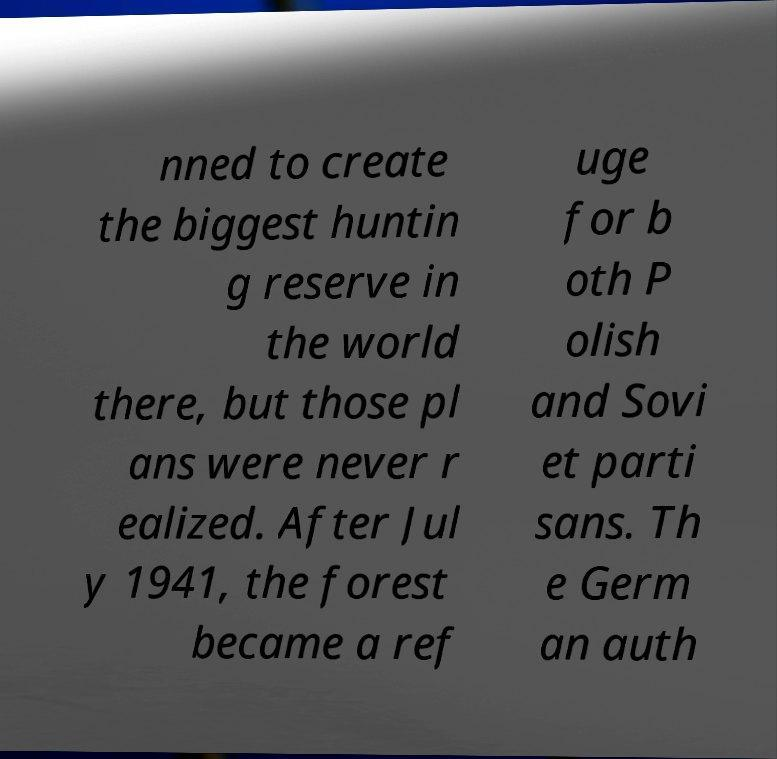For documentation purposes, I need the text within this image transcribed. Could you provide that? nned to create the biggest huntin g reserve in the world there, but those pl ans were never r ealized. After Jul y 1941, the forest became a ref uge for b oth P olish and Sovi et parti sans. Th e Germ an auth 